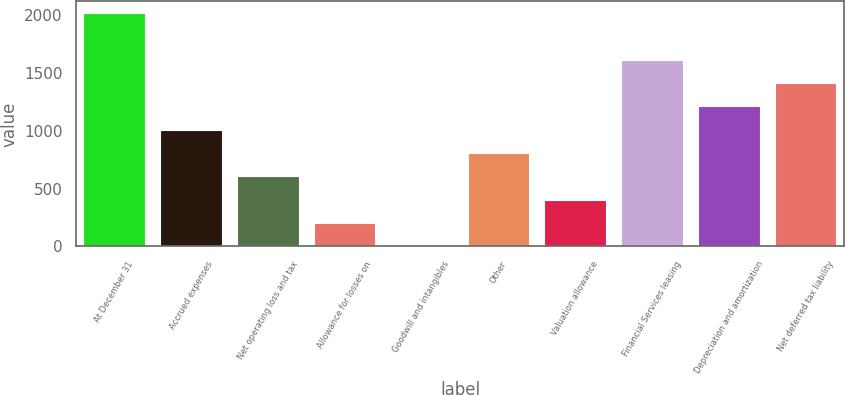<chart> <loc_0><loc_0><loc_500><loc_500><bar_chart><fcel>At December 31<fcel>Accrued expenses<fcel>Net operating loss and tax<fcel>Allowance for losses on<fcel>Goodwill and intangibles<fcel>Other<fcel>Valuation allowance<fcel>Financial Services leasing<fcel>Depreciation and amortization<fcel>Net deferred tax liability<nl><fcel>2016<fcel>1008.65<fcel>605.71<fcel>202.77<fcel>1.3<fcel>807.18<fcel>404.24<fcel>1613.06<fcel>1210.12<fcel>1411.59<nl></chart> 